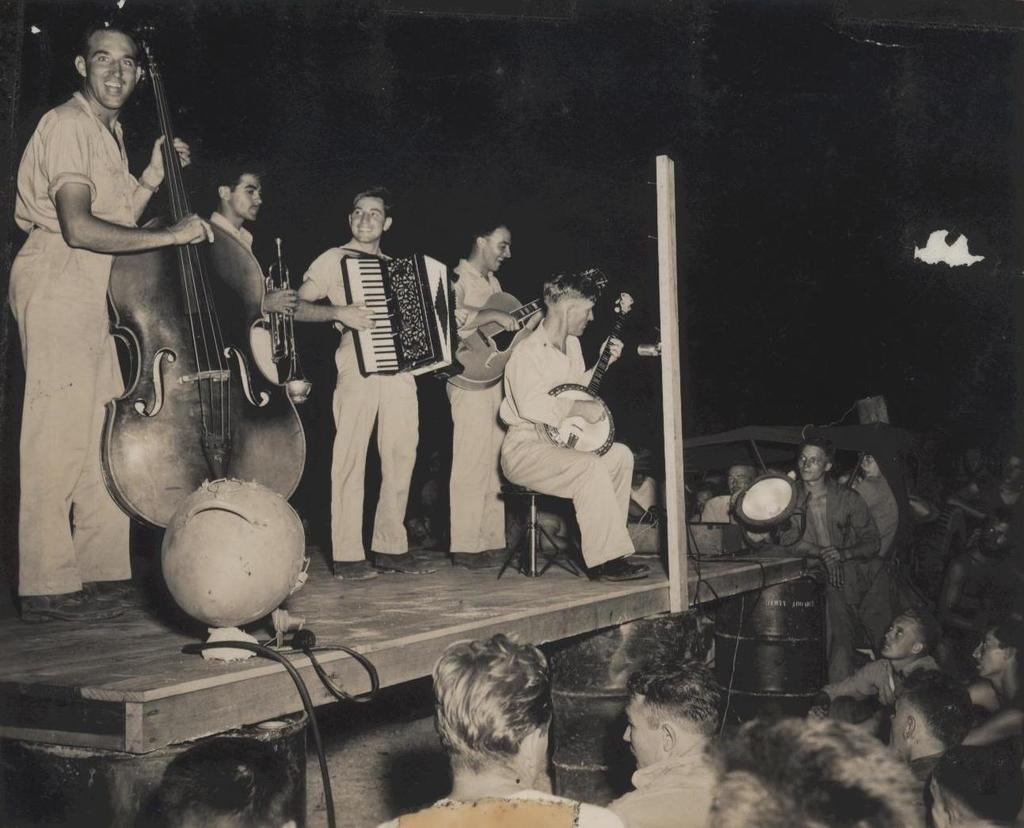What is happening in the image involving the group of people? There is a group of people playing musical instruments in the image. Are there any other people present in the image besides the musicians? Yes, there are additional people standing in front of the group. What is the color scheme of the image? The image is black and white. Are there any slaves depicted in the image? There is no mention of slaves or any indication of slavery in the image. The image features a group of people playing musical instruments and additional people standing in front of them. 